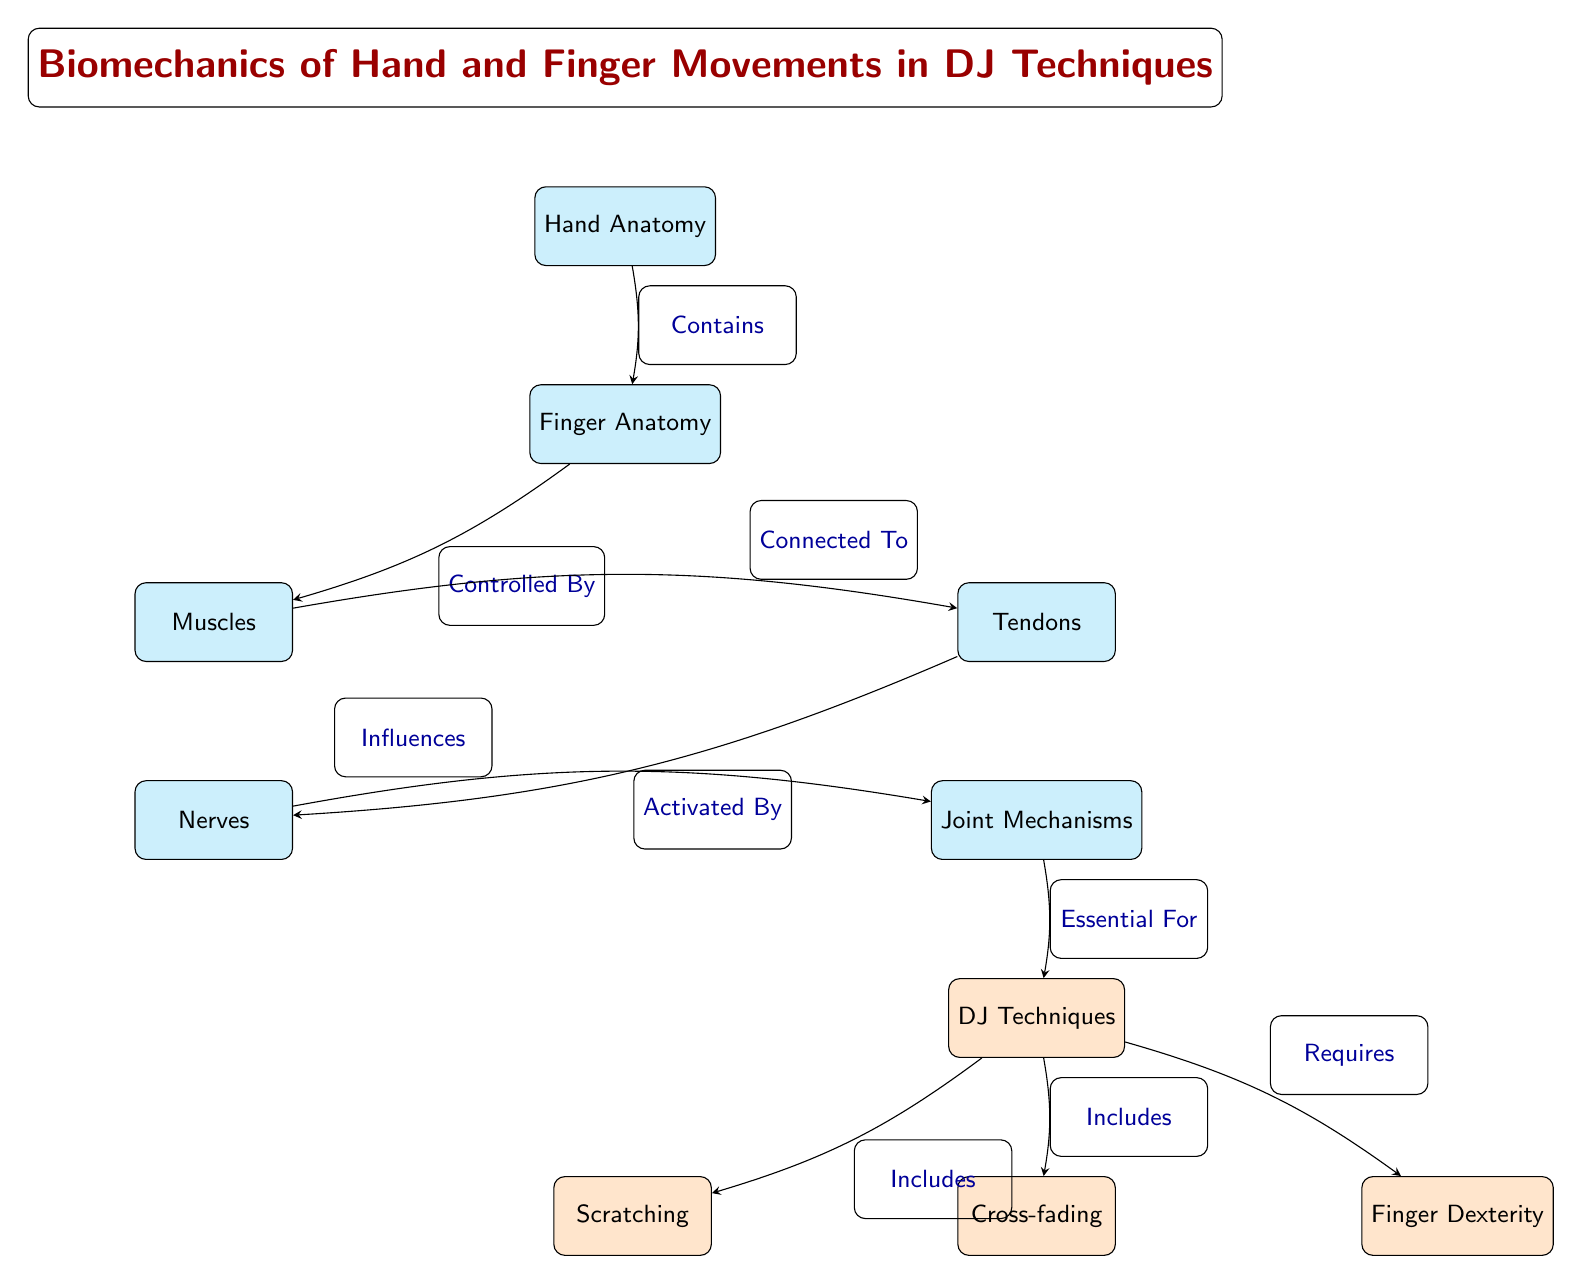What is the main focus of the diagram? The title at the top of the diagram states "Biomechanics of Hand and Finger Movements in DJ Techniques," indicating that this is the primary subject being addressed.
Answer: Biomechanics of Hand and Finger Movements in DJ Techniques How many main nodes are present in the diagram? The diagram displays a total of six main nodes (Hand Anatomy, Finger Anatomy, Muscles, Tendons, Nerves, Joint Mechanisms), plus three technique nodes (Scratching, Cross-fading, Dexterity), totaling nine displayed nodes.
Answer: 9 What does the 'Nerves' node influence? The edge connecting the 'Nerves' node to the 'Joints' node is labeled "Influences," indicating that nerves have an effect on the functioning of joints.
Answer: Joints Which node is connected to 'Muscles'? The edge between 'Finger Anatomy' and 'Muscles' is labeled "Controlled By," showing that fingers' movements are controlled by muscles.
Answer: Muscles Which DJ technique requires finger dexterity? The edge connecting the 'Techniques' node to the 'Dexterity' node is labeled "Requires," illustrating that dexterity is essential for executing DJ techniques.
Answer: Dexterity What is the relationship between 'Muscles' and 'Tendons'? The diagram shows a connection between 'Muscles' and 'Tendons' labeled "Connected To," indicating that muscles have a direct relationship with tendons.
Answer: Connected To Which technique is categorized under the DJ Techniques node? The edges from the 'Techniques' node to 'Scratching' and 'Cross-fading' are labeled "Includes," denoting these techniques as subsets of the broader category of DJ Techniques.
Answer: Scratching, Cross-fading What anatomical structure contains the fingers? The diagram shows an edge labeled "Contains" that connects 'Hand Anatomy' to 'Finger Anatomy', indicating that fingers are a part of the hand anatomy.
Answer: Hand Anatomy What is essential for the execution of DJ techniques? The relationship between 'Joints' and 'Techniques' is reflected in the edge labeled "Essential For," signifying that joint mechanisms are crucial for performing DJ techniques.
Answer: Joint Mechanisms 